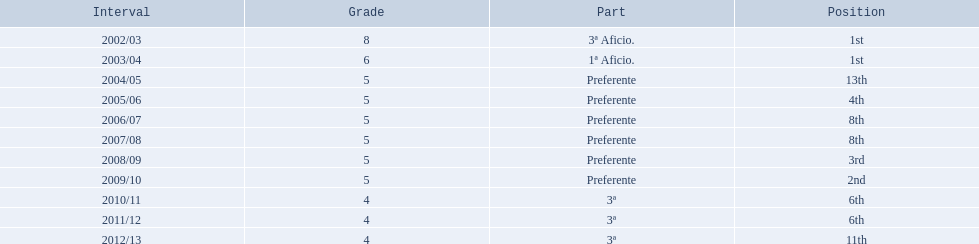What place did the team place in 2010/11? 6th. In what other year did they place 6th? 2011/12. 